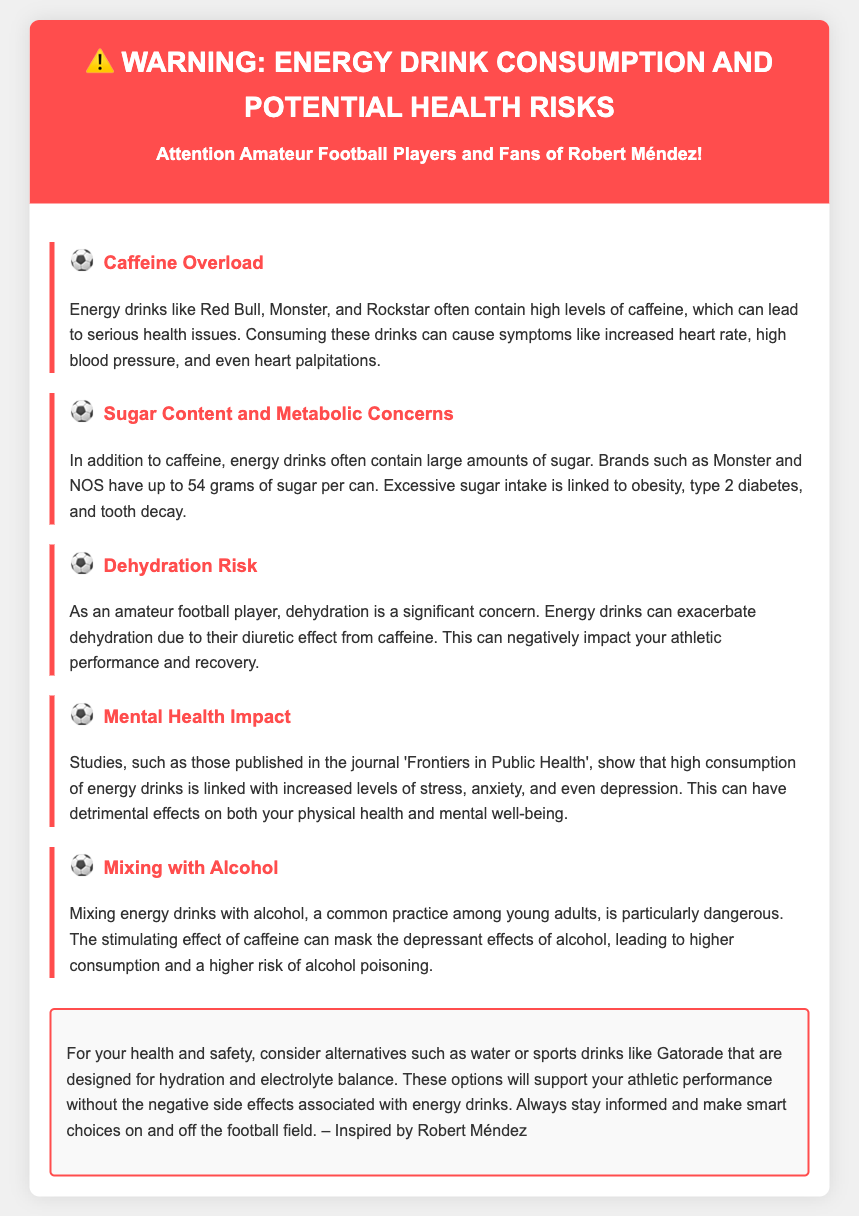What is the primary health concern associated with caffeine in energy drinks? The document states that energy drinks can lead to serious health issues such as increased heart rate, high blood pressure, and heart palpitations due to high levels of caffeine.
Answer: Caffeine Overload How much sugar can energy drinks like Monster contain? The document mentions that brands such as Monster can have up to 54 grams of sugar per can.
Answer: 54 grams What is a significant risk for amateur football players when consuming energy drinks? The document highlights that energy drinks can exacerbate dehydration due to their diuretic effect, impacting athletic performance.
Answer: Dehydration Risk What mental health issues are linked to high consumption of energy drinks? According to the document, high consumption of energy drinks is associated with increased levels of stress, anxiety, and depression.
Answer: Mental Health Impact What is recommended as a healthier alternative to energy drinks? The document suggests alternatives like water or sports drinks designed for hydration and electrolyte balance.
Answer: Water or sports drinks What effect can mixing energy drinks with alcohol have? The document warns that mixing energy drinks with alcohol can mask the depressant effects of alcohol, leading to higher consumption and risk.
Answer: Higher consumption Which publication is referenced concerning mental health impacts from energy drinks? The document mentions that studies published in the journal 'Frontiers in Public Health' discuss the mental health impacts of energy drink consumption.
Answer: Frontiers in Public Health What is the overarching message of the warning label? The document advises readers to stay informed and make smart choices regarding energy drink consumption, promoting health and safety.
Answer: Health and safety 